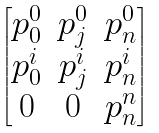<formula> <loc_0><loc_0><loc_500><loc_500>\begin{bmatrix} p ^ { 0 } _ { 0 } & p ^ { 0 } _ { j } & p ^ { 0 } _ { n } \\ p ^ { i } _ { 0 } & p ^ { i } _ { j } & p ^ { i } _ { n } \\ 0 & 0 & p ^ { n } _ { n } \end{bmatrix}</formula> 